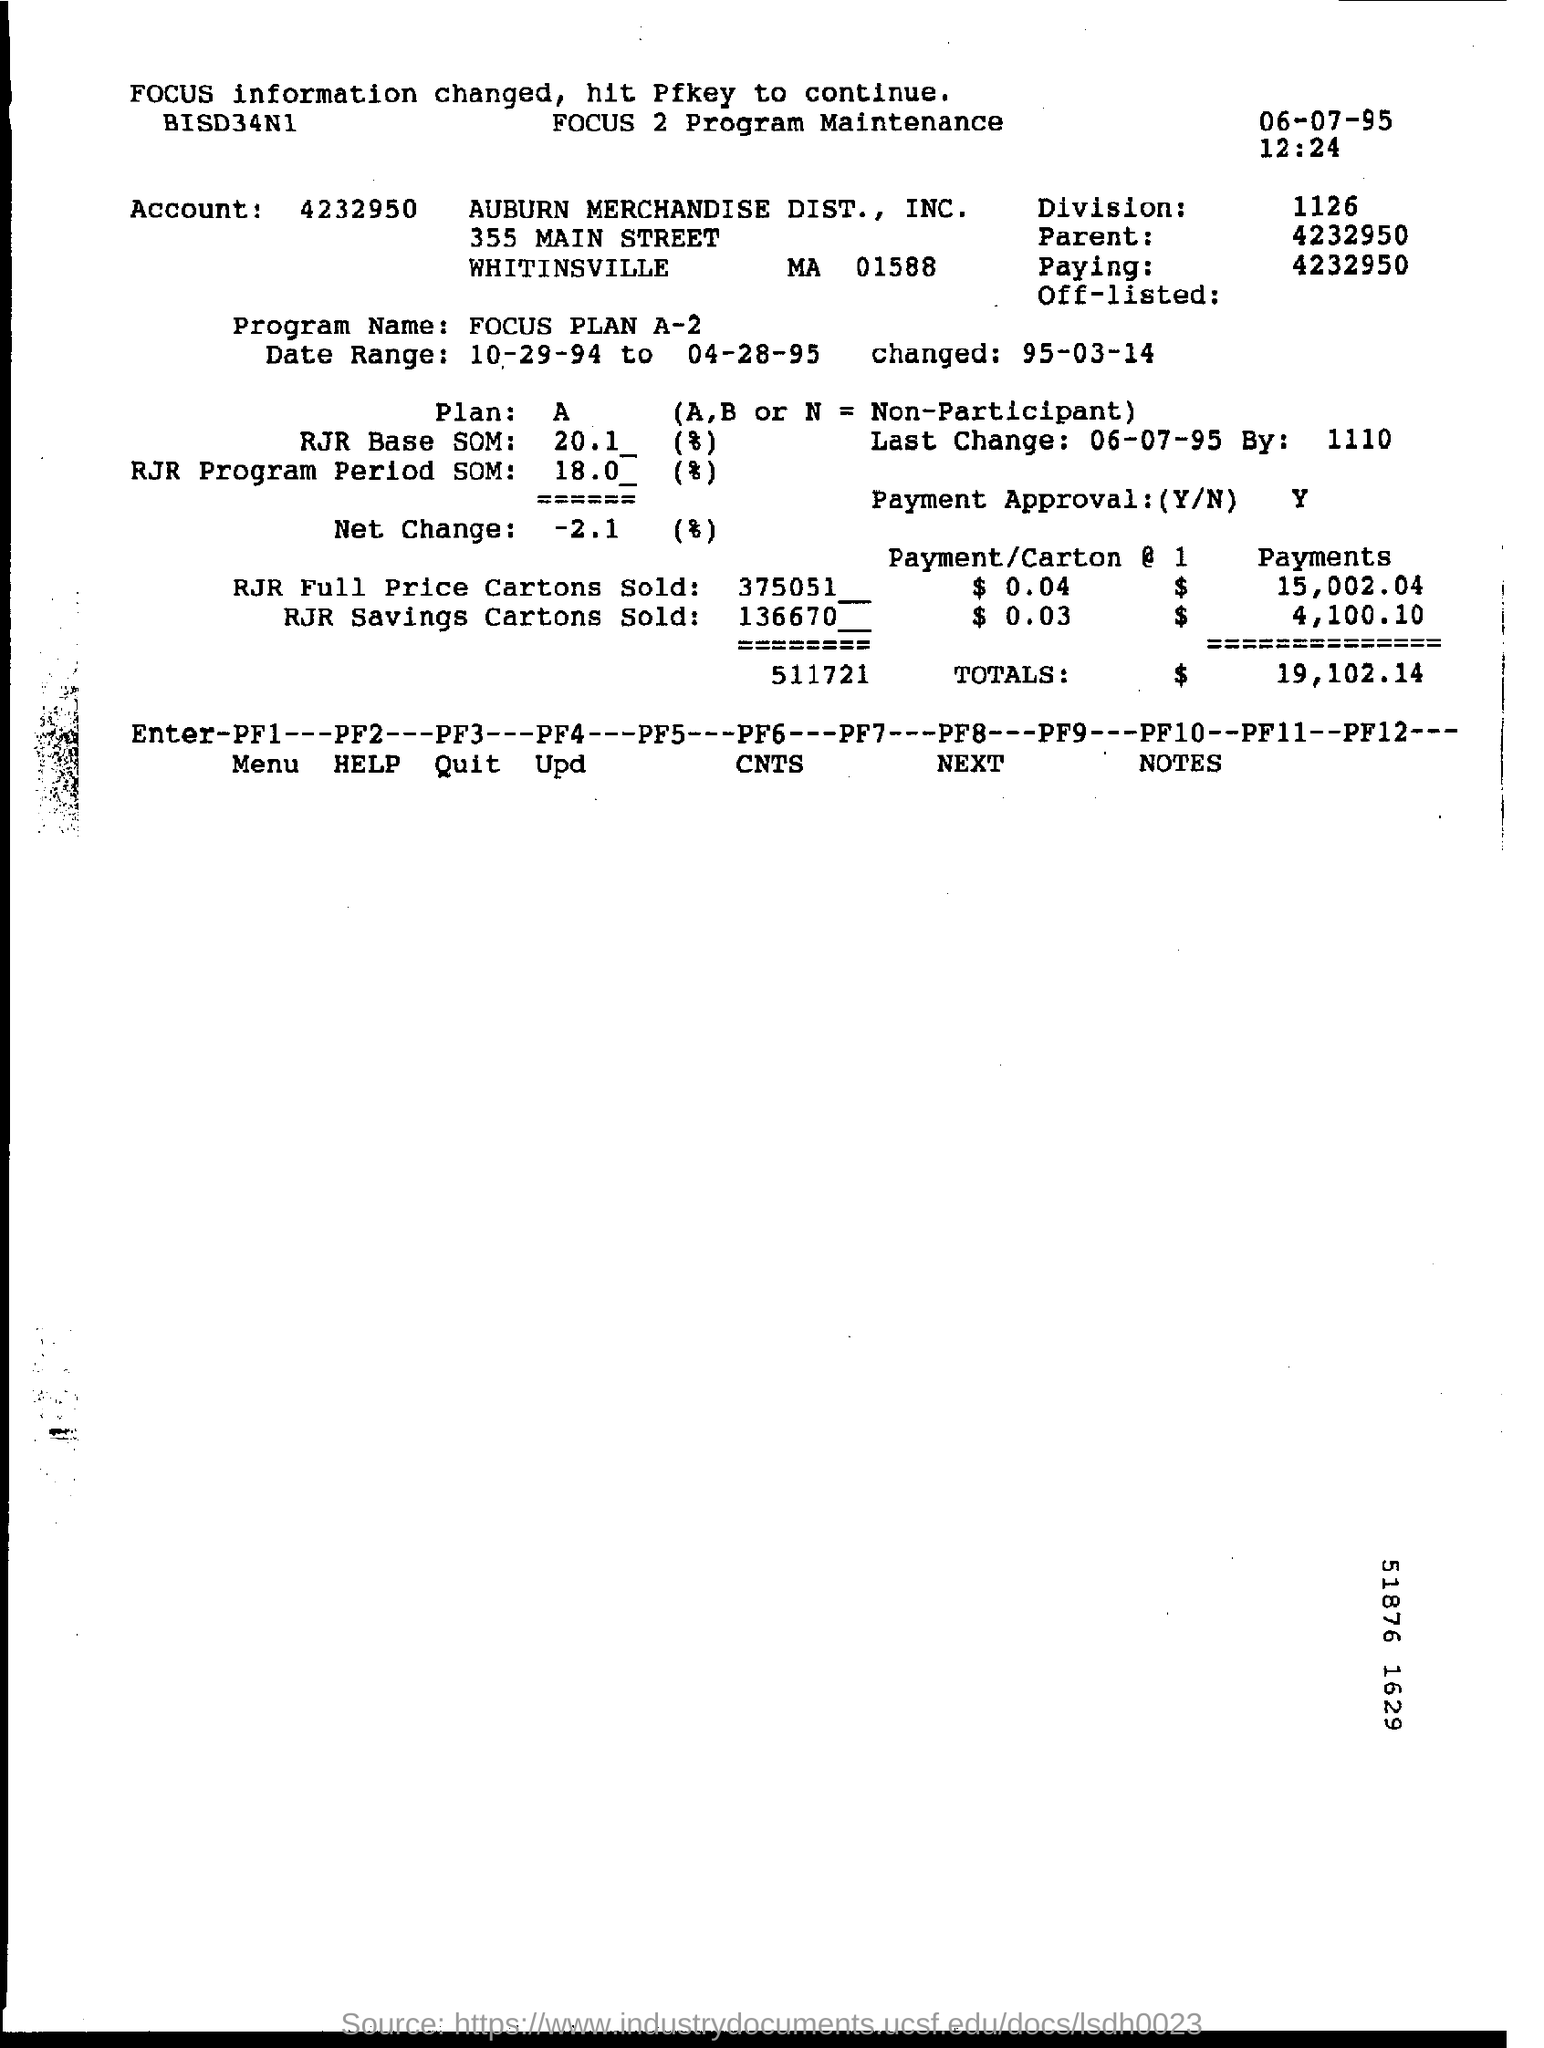Outline some significant characteristics in this image. The account number is 4232950... The division number is 1126. The date mentioned is 06-07-95. The time mentioned in the document is 12:24.. 